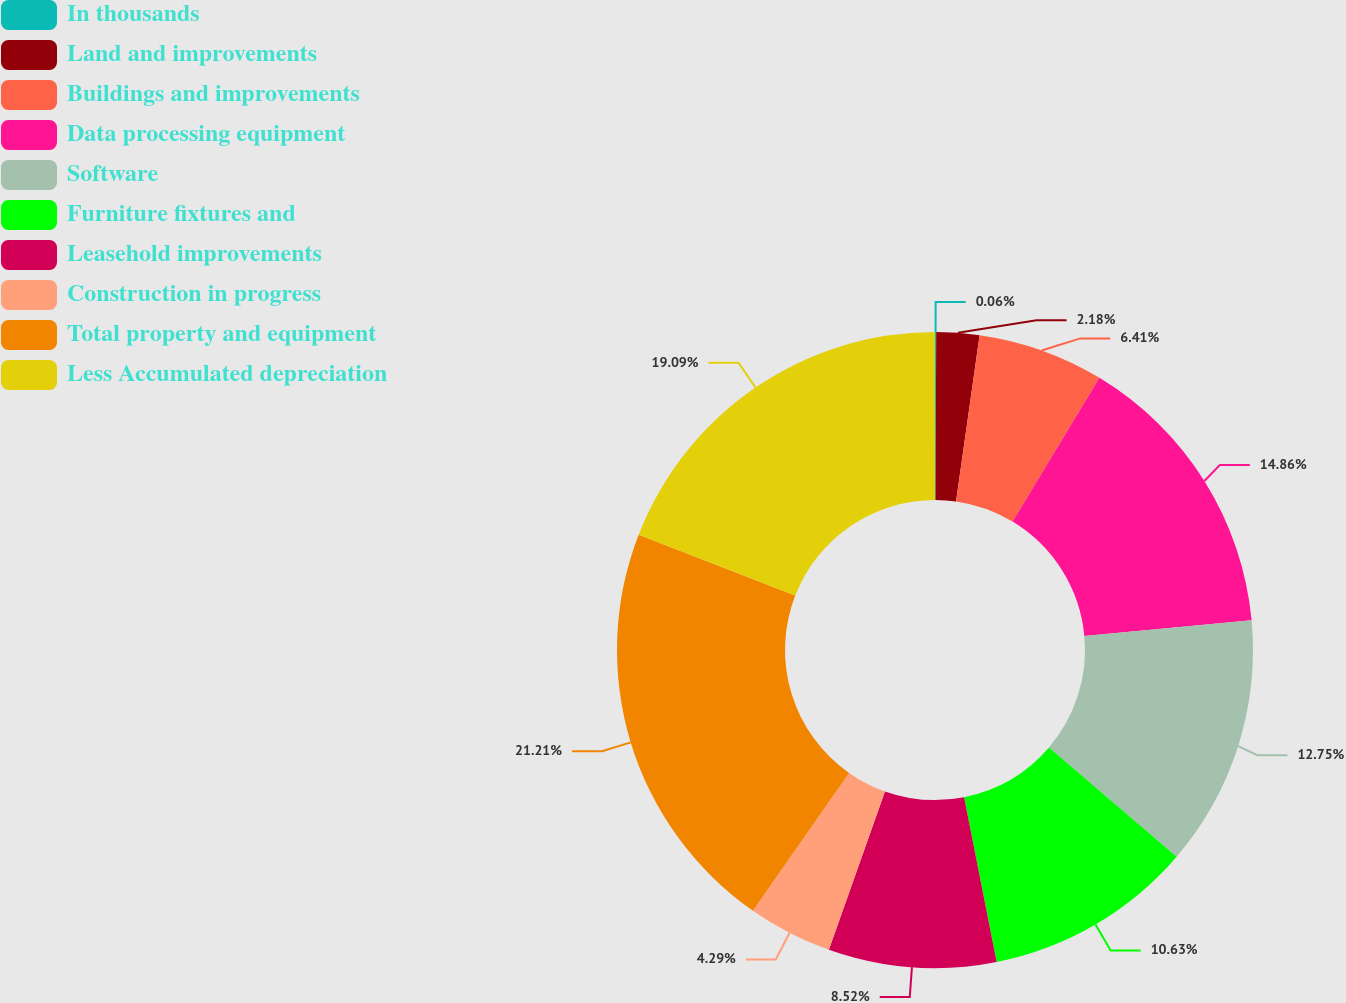Convert chart to OTSL. <chart><loc_0><loc_0><loc_500><loc_500><pie_chart><fcel>In thousands<fcel>Land and improvements<fcel>Buildings and improvements<fcel>Data processing equipment<fcel>Software<fcel>Furniture fixtures and<fcel>Leasehold improvements<fcel>Construction in progress<fcel>Total property and equipment<fcel>Less Accumulated depreciation<nl><fcel>0.06%<fcel>2.18%<fcel>6.41%<fcel>14.86%<fcel>12.75%<fcel>10.63%<fcel>8.52%<fcel>4.29%<fcel>21.2%<fcel>19.09%<nl></chart> 